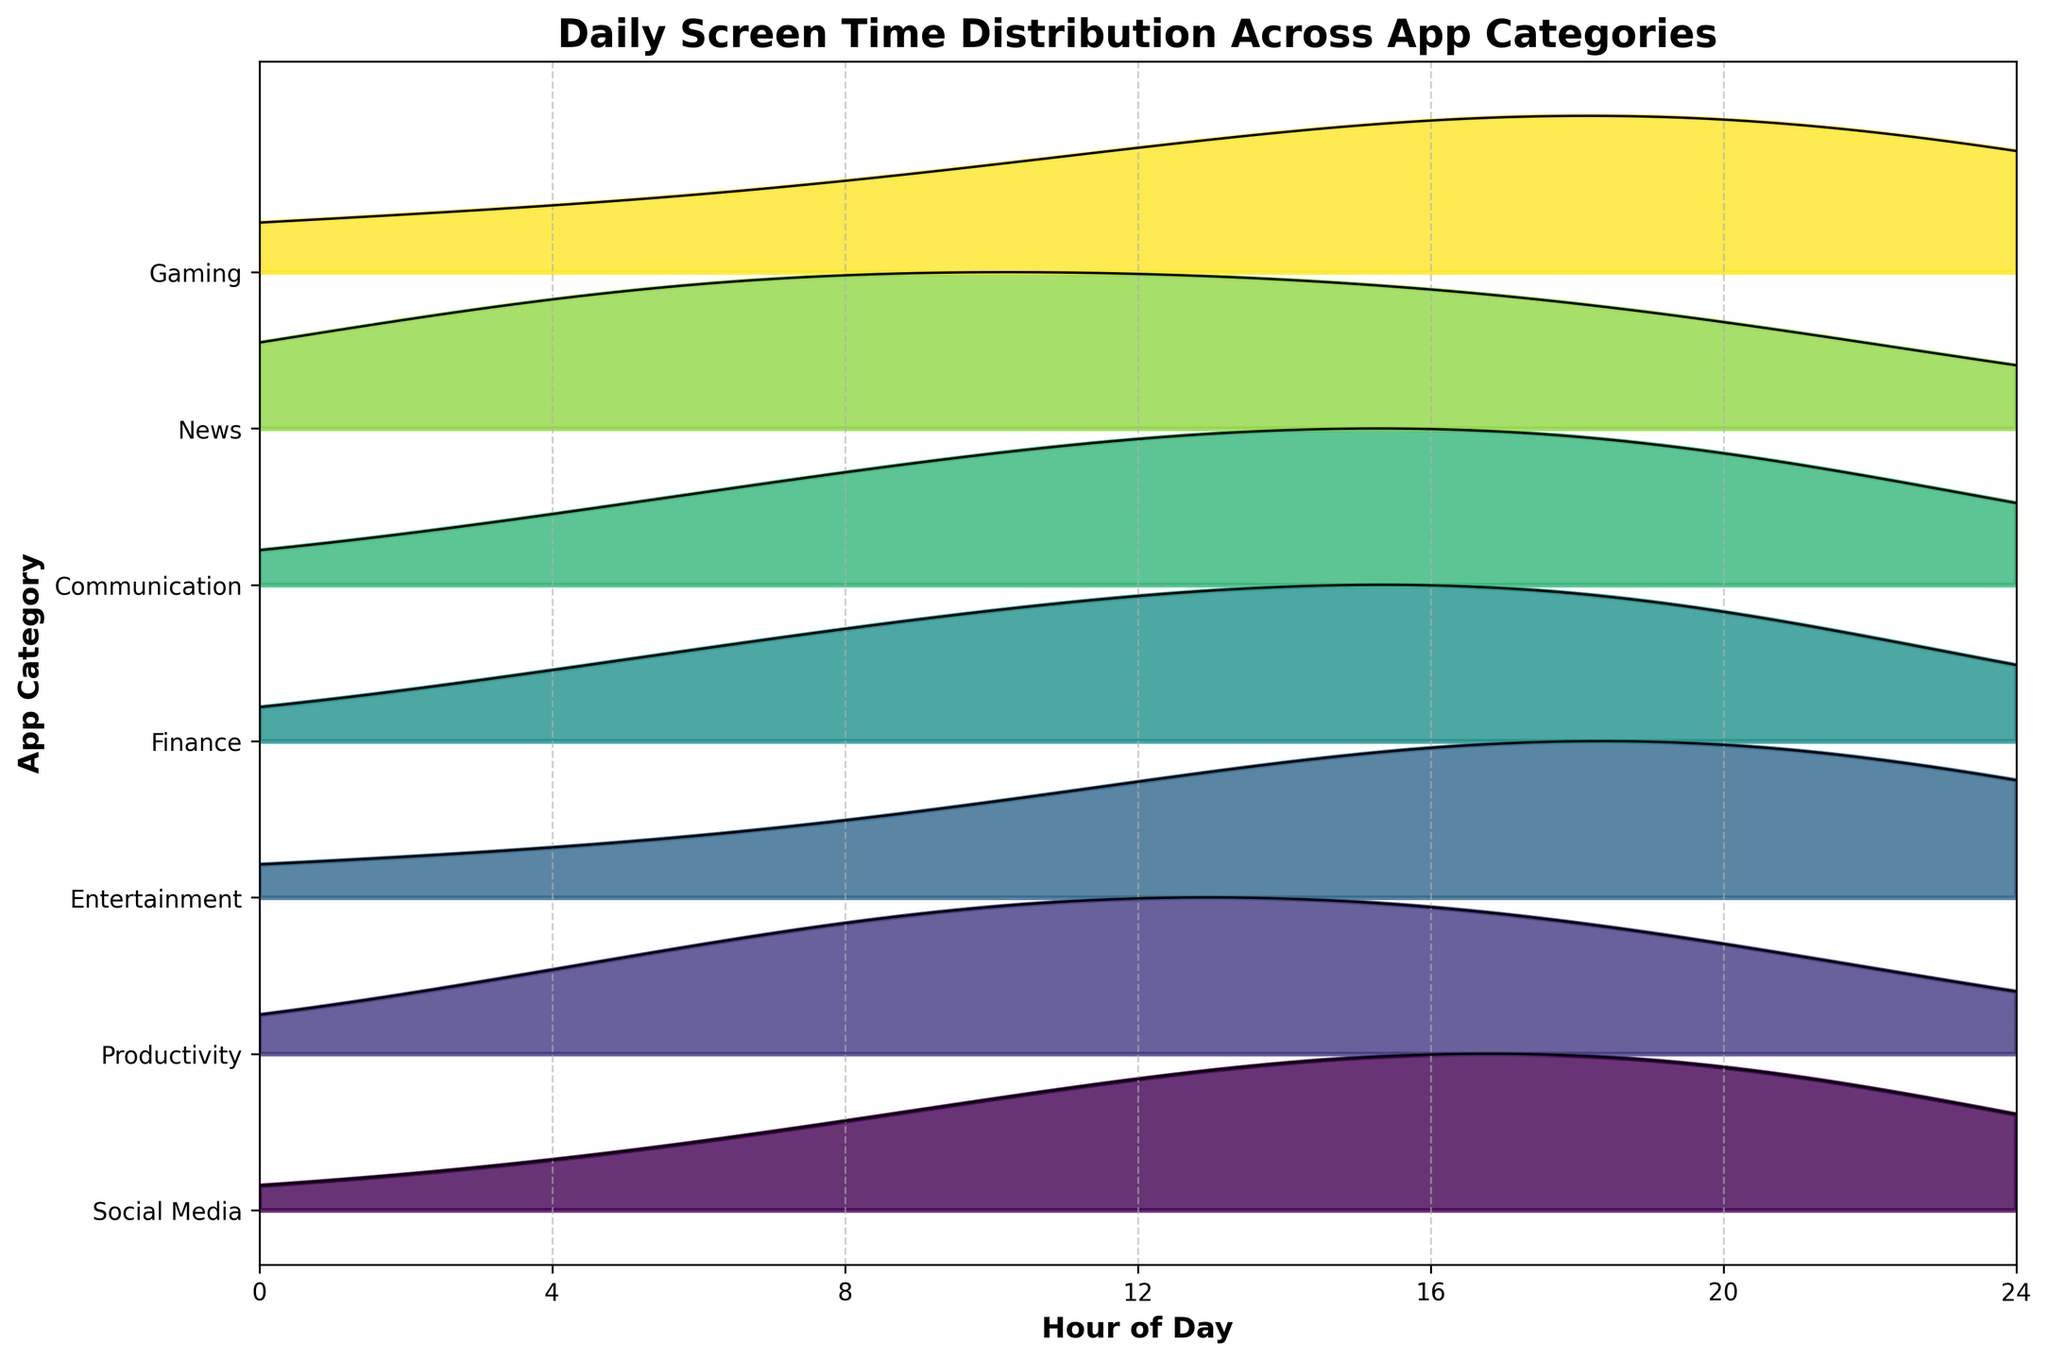What is the title of the figure? The title is located at the top of the figure and is usually the largest text. It reads "Daily Screen Time Distribution Across App Categories".
Answer: Daily Screen Time Distribution Across App Categories What is the app category with the highest screen time around 12 PM? Around 12 PM, we observe the height of the ridgeline peaks. The highest peak belongs to the "Social Media" category.
Answer: Social Media Which app category has the least screen time distribution around 6 AM? Around 6 AM, we observe the height of the ridgeline peaks. The smallest peak belongs to the "Gaming" category.
Answer: Gaming How many app categories are compared in this figure? Count the distinct app categories listed on the y-axis. There are 7 categories: Social Media, Productivity, Entertainment, Finance, Communication, News, and Gaming.
Answer: 7 Which app category shows a significant peak in screen time usage around 6 PM to 7 PM? Between 6 PM to 7 PM, the ridgeline peaks indicate that "Entertainment" has the most significant screen time usage.
Answer: Entertainment During which hours does the "Finance" category have a noticeable screen time distribution? The "Finance" category shows smaller peaks at 12 PM and 6 PM. These hours indicate when the screen time distribution is noticeable for Finance.
Answer: 12 PM and 6 PM Compare the screen time peaks of "Communication" and "News" at 6 AM. Which category shows higher screen time? At 6 AM, compare the two ridgelines. "News" has a higher peak compared to "Communication".
Answer: News What time of day shows the highest screen time for "Gaming"? Observe the ridgeline for "Gaming". It peaks the most noticeably around 6 PM.
Answer: 6 PM What is the trend observed in screen time for "Productivity" throughout the day? The "Productivity" category shows peaks at 6 AM, 12 PM, and 6 PM, with the highest peak at 12 PM, indicating consistent usage during work hours.
Answer: Peaks at 6 AM, 12 PM, and 6 PM How does the screen time distribution for "Entertainment" at midnight compare to "Social Media"? Around midnight (0 hour), "Entertainment" has a more substantial peak than "Social Media", indicating higher usage.
Answer: Entertainment has more usage than Social Media 